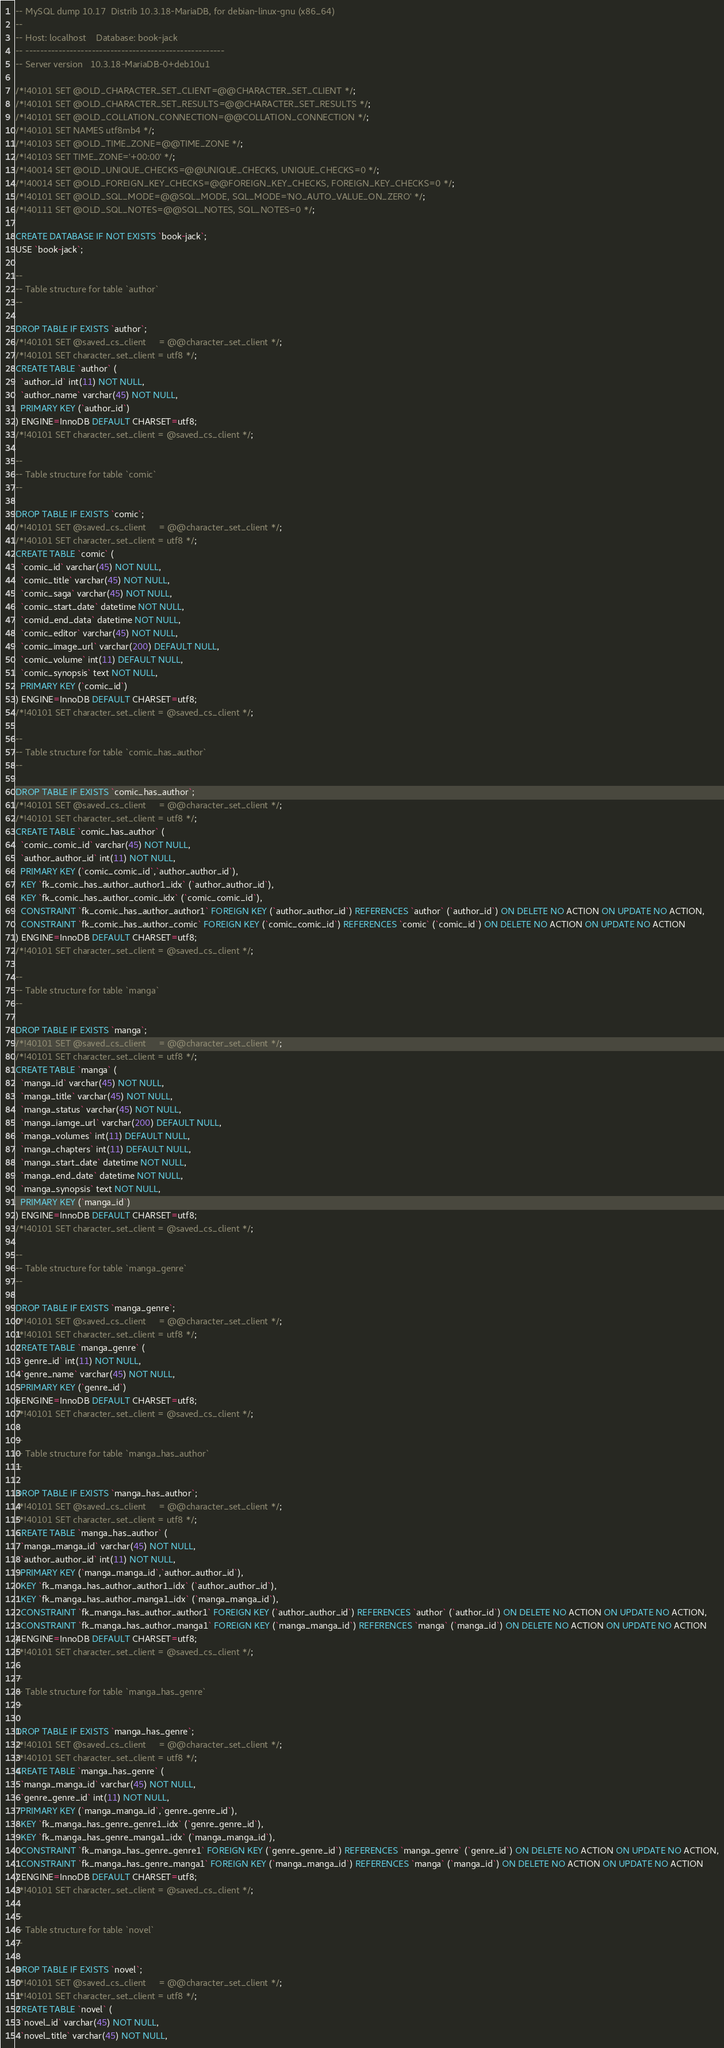<code> <loc_0><loc_0><loc_500><loc_500><_SQL_>-- MySQL dump 10.17  Distrib 10.3.18-MariaDB, for debian-linux-gnu (x86_64)
--
-- Host: localhost    Database: book-jack
-- ------------------------------------------------------
-- Server version	10.3.18-MariaDB-0+deb10u1

/*!40101 SET @OLD_CHARACTER_SET_CLIENT=@@CHARACTER_SET_CLIENT */;
/*!40101 SET @OLD_CHARACTER_SET_RESULTS=@@CHARACTER_SET_RESULTS */;
/*!40101 SET @OLD_COLLATION_CONNECTION=@@COLLATION_CONNECTION */;
/*!40101 SET NAMES utf8mb4 */;
/*!40103 SET @OLD_TIME_ZONE=@@TIME_ZONE */;
/*!40103 SET TIME_ZONE='+00:00' */;
/*!40014 SET @OLD_UNIQUE_CHECKS=@@UNIQUE_CHECKS, UNIQUE_CHECKS=0 */;
/*!40014 SET @OLD_FOREIGN_KEY_CHECKS=@@FOREIGN_KEY_CHECKS, FOREIGN_KEY_CHECKS=0 */;
/*!40101 SET @OLD_SQL_MODE=@@SQL_MODE, SQL_MODE='NO_AUTO_VALUE_ON_ZERO' */;
/*!40111 SET @OLD_SQL_NOTES=@@SQL_NOTES, SQL_NOTES=0 */;

CREATE DATABASE IF NOT EXISTS `book-jack`;
USE `book-jack`;

--
-- Table structure for table `author`
--

DROP TABLE IF EXISTS `author`;
/*!40101 SET @saved_cs_client     = @@character_set_client */;
/*!40101 SET character_set_client = utf8 */;
CREATE TABLE `author` (
  `author_id` int(11) NOT NULL,
  `author_name` varchar(45) NOT NULL,
  PRIMARY KEY (`author_id`)
) ENGINE=InnoDB DEFAULT CHARSET=utf8;
/*!40101 SET character_set_client = @saved_cs_client */;

--
-- Table structure for table `comic`
--

DROP TABLE IF EXISTS `comic`;
/*!40101 SET @saved_cs_client     = @@character_set_client */;
/*!40101 SET character_set_client = utf8 */;
CREATE TABLE `comic` (
  `comic_id` varchar(45) NOT NULL,
  `comic_title` varchar(45) NOT NULL,
  `comic_saga` varchar(45) NOT NULL,
  `comic_start_date` datetime NOT NULL,
  `comid_end_data` datetime NOT NULL,
  `comic_editor` varchar(45) NOT NULL,
  `comic_image_url` varchar(200) DEFAULT NULL,
  `comic_volume` int(11) DEFAULT NULL,
  `comic_synopsis` text NOT NULL,
  PRIMARY KEY (`comic_id`)
) ENGINE=InnoDB DEFAULT CHARSET=utf8;
/*!40101 SET character_set_client = @saved_cs_client */;

--
-- Table structure for table `comic_has_author`
--

DROP TABLE IF EXISTS `comic_has_author`;
/*!40101 SET @saved_cs_client     = @@character_set_client */;
/*!40101 SET character_set_client = utf8 */;
CREATE TABLE `comic_has_author` (
  `comic_comic_id` varchar(45) NOT NULL,
  `author_author_id` int(11) NOT NULL,
  PRIMARY KEY (`comic_comic_id`,`author_author_id`),
  KEY `fk_comic_has_author_author1_idx` (`author_author_id`),
  KEY `fk_comic_has_author_comic_idx` (`comic_comic_id`),
  CONSTRAINT `fk_comic_has_author_author1` FOREIGN KEY (`author_author_id`) REFERENCES `author` (`author_id`) ON DELETE NO ACTION ON UPDATE NO ACTION,
  CONSTRAINT `fk_comic_has_author_comic` FOREIGN KEY (`comic_comic_id`) REFERENCES `comic` (`comic_id`) ON DELETE NO ACTION ON UPDATE NO ACTION
) ENGINE=InnoDB DEFAULT CHARSET=utf8;
/*!40101 SET character_set_client = @saved_cs_client */;

--
-- Table structure for table `manga`
--

DROP TABLE IF EXISTS `manga`;
/*!40101 SET @saved_cs_client     = @@character_set_client */;
/*!40101 SET character_set_client = utf8 */;
CREATE TABLE `manga` (
  `manga_id` varchar(45) NOT NULL,
  `manga_title` varchar(45) NOT NULL,
  `manga_status` varchar(45) NOT NULL,
  `manga_iamge_url` varchar(200) DEFAULT NULL,
  `manga_volumes` int(11) DEFAULT NULL,
  `manga_chapters` int(11) DEFAULT NULL,
  `manga_start_date` datetime NOT NULL,
  `manga_end_date` datetime NOT NULL,
  `manga_synopsis` text NOT NULL,
  PRIMARY KEY (`manga_id`)
) ENGINE=InnoDB DEFAULT CHARSET=utf8;
/*!40101 SET character_set_client = @saved_cs_client */;

--
-- Table structure for table `manga_genre`
--

DROP TABLE IF EXISTS `manga_genre`;
/*!40101 SET @saved_cs_client     = @@character_set_client */;
/*!40101 SET character_set_client = utf8 */;
CREATE TABLE `manga_genre` (
  `genre_id` int(11) NOT NULL,
  `genre_name` varchar(45) NOT NULL,
  PRIMARY KEY (`genre_id`)
) ENGINE=InnoDB DEFAULT CHARSET=utf8;
/*!40101 SET character_set_client = @saved_cs_client */;

--
-- Table structure for table `manga_has_author`
--

DROP TABLE IF EXISTS `manga_has_author`;
/*!40101 SET @saved_cs_client     = @@character_set_client */;
/*!40101 SET character_set_client = utf8 */;
CREATE TABLE `manga_has_author` (
  `manga_manga_id` varchar(45) NOT NULL,
  `author_author_id` int(11) NOT NULL,
  PRIMARY KEY (`manga_manga_id`,`author_author_id`),
  KEY `fk_manga_has_author_author1_idx` (`author_author_id`),
  KEY `fk_manga_has_author_manga1_idx` (`manga_manga_id`),
  CONSTRAINT `fk_manga_has_author_author1` FOREIGN KEY (`author_author_id`) REFERENCES `author` (`author_id`) ON DELETE NO ACTION ON UPDATE NO ACTION,
  CONSTRAINT `fk_manga_has_author_manga1` FOREIGN KEY (`manga_manga_id`) REFERENCES `manga` (`manga_id`) ON DELETE NO ACTION ON UPDATE NO ACTION
) ENGINE=InnoDB DEFAULT CHARSET=utf8;
/*!40101 SET character_set_client = @saved_cs_client */;

--
-- Table structure for table `manga_has_genre`
--

DROP TABLE IF EXISTS `manga_has_genre`;
/*!40101 SET @saved_cs_client     = @@character_set_client */;
/*!40101 SET character_set_client = utf8 */;
CREATE TABLE `manga_has_genre` (
  `manga_manga_id` varchar(45) NOT NULL,
  `genre_genre_id` int(11) NOT NULL,
  PRIMARY KEY (`manga_manga_id`,`genre_genre_id`),
  KEY `fk_manga_has_genre_genre1_idx` (`genre_genre_id`),
  KEY `fk_manga_has_genre_manga1_idx` (`manga_manga_id`),
  CONSTRAINT `fk_manga_has_genre_genre1` FOREIGN KEY (`genre_genre_id`) REFERENCES `manga_genre` (`genre_id`) ON DELETE NO ACTION ON UPDATE NO ACTION,
  CONSTRAINT `fk_manga_has_genre_manga1` FOREIGN KEY (`manga_manga_id`) REFERENCES `manga` (`manga_id`) ON DELETE NO ACTION ON UPDATE NO ACTION
) ENGINE=InnoDB DEFAULT CHARSET=utf8;
/*!40101 SET character_set_client = @saved_cs_client */;

--
-- Table structure for table `novel`
--

DROP TABLE IF EXISTS `novel`;
/*!40101 SET @saved_cs_client     = @@character_set_client */;
/*!40101 SET character_set_client = utf8 */;
CREATE TABLE `novel` (
  `novel_id` varchar(45) NOT NULL,
  `novel_title` varchar(45) NOT NULL,</code> 